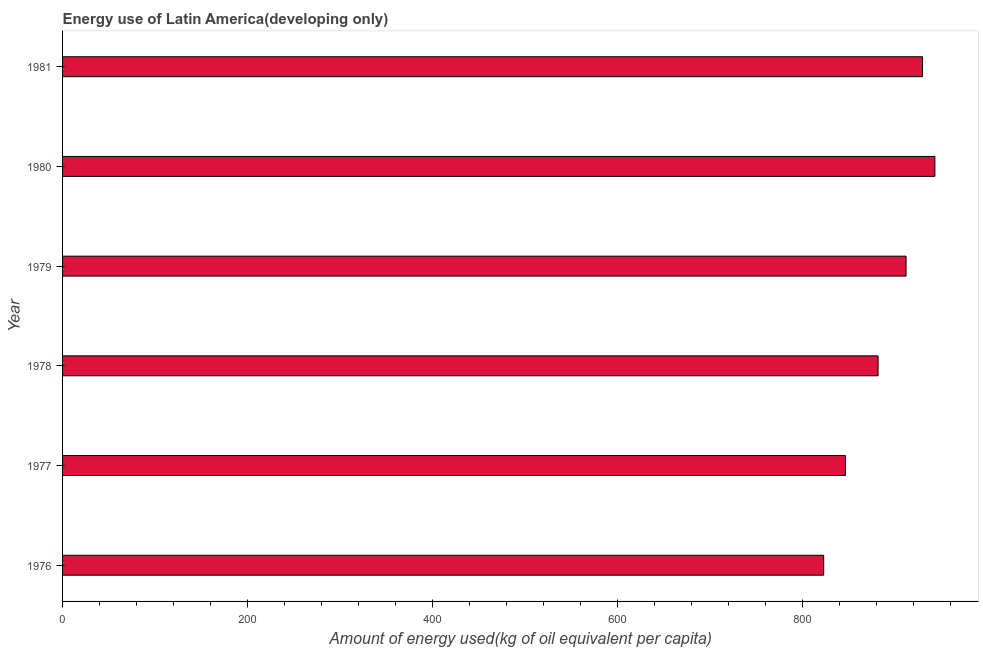Does the graph contain any zero values?
Make the answer very short. No. What is the title of the graph?
Provide a short and direct response. Energy use of Latin America(developing only). What is the label or title of the X-axis?
Ensure brevity in your answer.  Amount of energy used(kg of oil equivalent per capita). What is the label or title of the Y-axis?
Your answer should be very brief. Year. What is the amount of energy used in 1977?
Provide a short and direct response. 846.04. Across all years, what is the maximum amount of energy used?
Your answer should be very brief. 942.73. Across all years, what is the minimum amount of energy used?
Provide a short and direct response. 822.56. In which year was the amount of energy used maximum?
Give a very brief answer. 1980. In which year was the amount of energy used minimum?
Keep it short and to the point. 1976. What is the sum of the amount of energy used?
Offer a terse response. 5333.62. What is the difference between the amount of energy used in 1976 and 1977?
Make the answer very short. -23.48. What is the average amount of energy used per year?
Provide a succinct answer. 888.94. What is the median amount of energy used?
Give a very brief answer. 896.46. In how many years, is the amount of energy used greater than 360 kg?
Offer a very short reply. 6. Do a majority of the years between 1976 and 1979 (inclusive) have amount of energy used greater than 840 kg?
Give a very brief answer. Yes. What is the ratio of the amount of energy used in 1976 to that in 1980?
Provide a succinct answer. 0.87. Is the difference between the amount of energy used in 1976 and 1978 greater than the difference between any two years?
Your answer should be compact. No. What is the difference between the highest and the second highest amount of energy used?
Give a very brief answer. 13.35. Is the sum of the amount of energy used in 1976 and 1978 greater than the maximum amount of energy used across all years?
Your answer should be compact. Yes. What is the difference between the highest and the lowest amount of energy used?
Your answer should be very brief. 120.16. In how many years, is the amount of energy used greater than the average amount of energy used taken over all years?
Offer a terse response. 3. Are the values on the major ticks of X-axis written in scientific E-notation?
Offer a very short reply. No. What is the Amount of energy used(kg of oil equivalent per capita) of 1976?
Provide a succinct answer. 822.56. What is the Amount of energy used(kg of oil equivalent per capita) of 1977?
Provide a succinct answer. 846.04. What is the Amount of energy used(kg of oil equivalent per capita) in 1978?
Your response must be concise. 881.34. What is the Amount of energy used(kg of oil equivalent per capita) in 1979?
Ensure brevity in your answer.  911.58. What is the Amount of energy used(kg of oil equivalent per capita) of 1980?
Make the answer very short. 942.73. What is the Amount of energy used(kg of oil equivalent per capita) in 1981?
Your answer should be very brief. 929.38. What is the difference between the Amount of energy used(kg of oil equivalent per capita) in 1976 and 1977?
Provide a succinct answer. -23.48. What is the difference between the Amount of energy used(kg of oil equivalent per capita) in 1976 and 1978?
Ensure brevity in your answer.  -58.78. What is the difference between the Amount of energy used(kg of oil equivalent per capita) in 1976 and 1979?
Your answer should be compact. -89.02. What is the difference between the Amount of energy used(kg of oil equivalent per capita) in 1976 and 1980?
Provide a short and direct response. -120.16. What is the difference between the Amount of energy used(kg of oil equivalent per capita) in 1976 and 1981?
Keep it short and to the point. -106.81. What is the difference between the Amount of energy used(kg of oil equivalent per capita) in 1977 and 1978?
Your response must be concise. -35.3. What is the difference between the Amount of energy used(kg of oil equivalent per capita) in 1977 and 1979?
Keep it short and to the point. -65.54. What is the difference between the Amount of energy used(kg of oil equivalent per capita) in 1977 and 1980?
Provide a succinct answer. -96.68. What is the difference between the Amount of energy used(kg of oil equivalent per capita) in 1977 and 1981?
Ensure brevity in your answer.  -83.33. What is the difference between the Amount of energy used(kg of oil equivalent per capita) in 1978 and 1979?
Make the answer very short. -30.24. What is the difference between the Amount of energy used(kg of oil equivalent per capita) in 1978 and 1980?
Keep it short and to the point. -61.39. What is the difference between the Amount of energy used(kg of oil equivalent per capita) in 1978 and 1981?
Offer a terse response. -48.04. What is the difference between the Amount of energy used(kg of oil equivalent per capita) in 1979 and 1980?
Your response must be concise. -31.15. What is the difference between the Amount of energy used(kg of oil equivalent per capita) in 1979 and 1981?
Offer a terse response. -17.8. What is the difference between the Amount of energy used(kg of oil equivalent per capita) in 1980 and 1981?
Make the answer very short. 13.35. What is the ratio of the Amount of energy used(kg of oil equivalent per capita) in 1976 to that in 1977?
Keep it short and to the point. 0.97. What is the ratio of the Amount of energy used(kg of oil equivalent per capita) in 1976 to that in 1978?
Your response must be concise. 0.93. What is the ratio of the Amount of energy used(kg of oil equivalent per capita) in 1976 to that in 1979?
Offer a terse response. 0.9. What is the ratio of the Amount of energy used(kg of oil equivalent per capita) in 1976 to that in 1980?
Provide a short and direct response. 0.87. What is the ratio of the Amount of energy used(kg of oil equivalent per capita) in 1976 to that in 1981?
Make the answer very short. 0.89. What is the ratio of the Amount of energy used(kg of oil equivalent per capita) in 1977 to that in 1979?
Provide a short and direct response. 0.93. What is the ratio of the Amount of energy used(kg of oil equivalent per capita) in 1977 to that in 1980?
Offer a very short reply. 0.9. What is the ratio of the Amount of energy used(kg of oil equivalent per capita) in 1977 to that in 1981?
Your answer should be compact. 0.91. What is the ratio of the Amount of energy used(kg of oil equivalent per capita) in 1978 to that in 1979?
Offer a very short reply. 0.97. What is the ratio of the Amount of energy used(kg of oil equivalent per capita) in 1978 to that in 1980?
Offer a terse response. 0.94. What is the ratio of the Amount of energy used(kg of oil equivalent per capita) in 1978 to that in 1981?
Offer a terse response. 0.95. What is the ratio of the Amount of energy used(kg of oil equivalent per capita) in 1979 to that in 1981?
Offer a very short reply. 0.98. What is the ratio of the Amount of energy used(kg of oil equivalent per capita) in 1980 to that in 1981?
Keep it short and to the point. 1.01. 